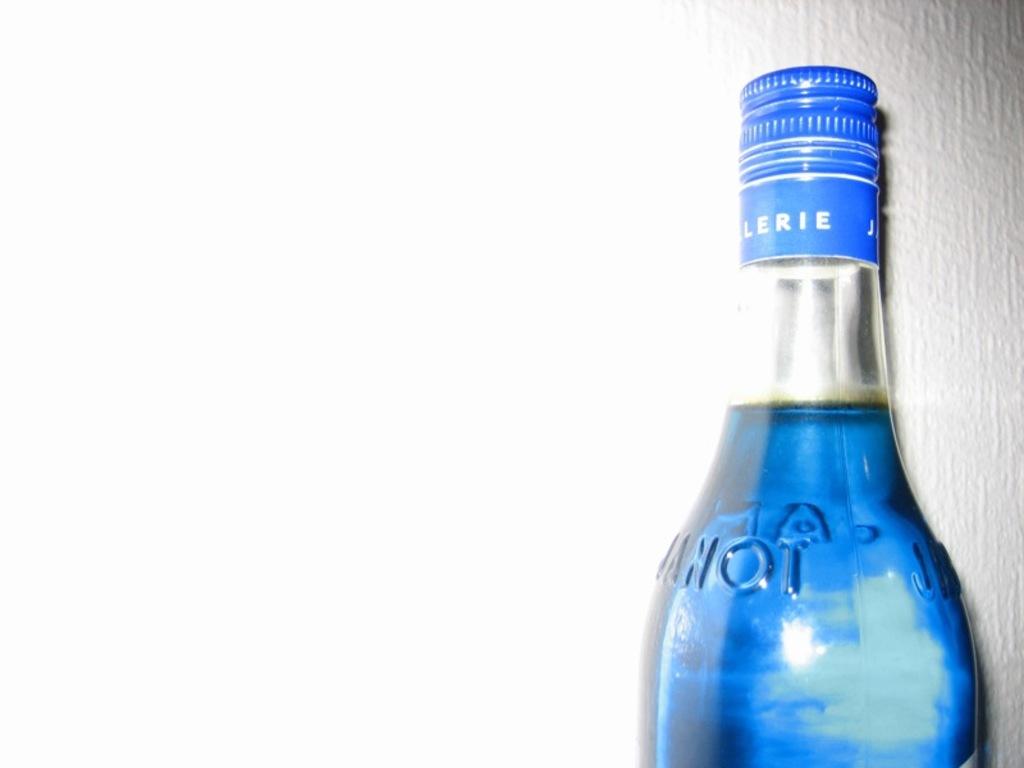What colour is the drink inside the bottle?
Provide a short and direct response. Answering does not require reading text in the image. Is lerie written on the bottle?
Give a very brief answer. Yes. 